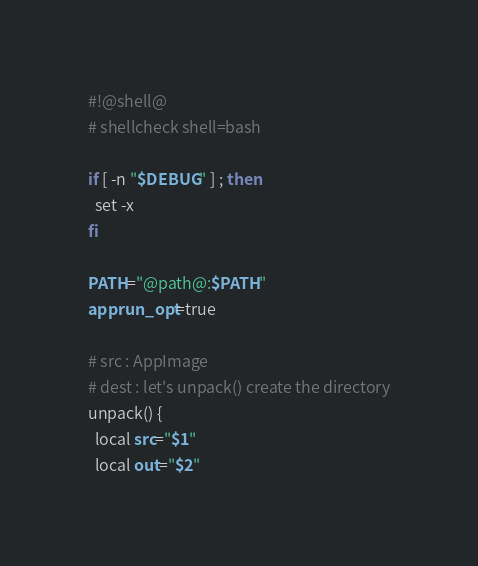<code> <loc_0><loc_0><loc_500><loc_500><_Bash_>#!@shell@
# shellcheck shell=bash

if [ -n "$DEBUG" ] ; then
  set -x
fi

PATH="@path@:$PATH"
apprun_opt=true

# src : AppImage
# dest : let's unpack() create the directory
unpack() {
  local src="$1"
  local out="$2"
</code> 